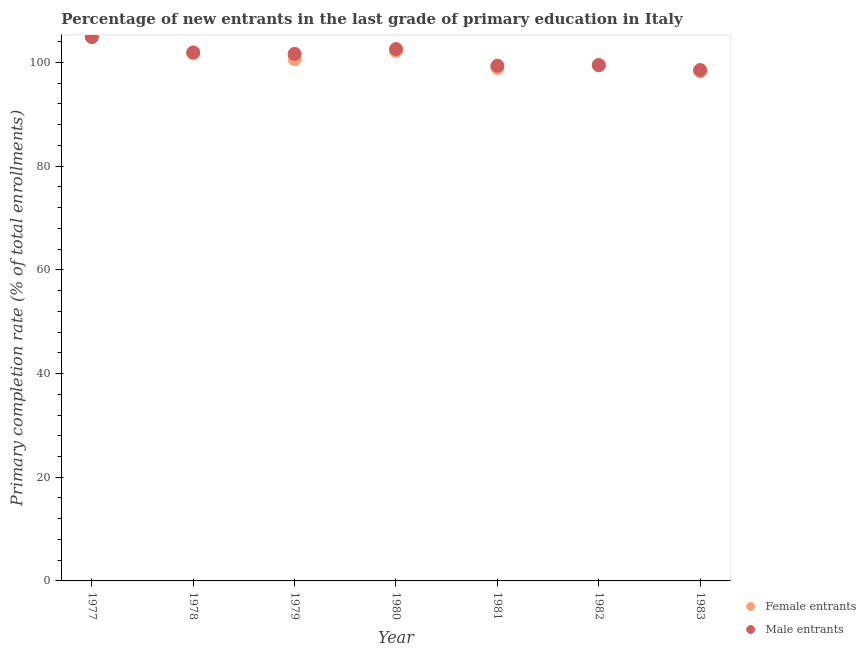What is the primary completion rate of male entrants in 1982?
Make the answer very short. 99.45. Across all years, what is the maximum primary completion rate of female entrants?
Give a very brief answer. 104.99. Across all years, what is the minimum primary completion rate of female entrants?
Make the answer very short. 98.28. In which year was the primary completion rate of female entrants minimum?
Provide a succinct answer. 1983. What is the total primary completion rate of female entrants in the graph?
Make the answer very short. 706.33. What is the difference between the primary completion rate of male entrants in 1978 and that in 1982?
Offer a terse response. 2.49. What is the difference between the primary completion rate of male entrants in 1982 and the primary completion rate of female entrants in 1981?
Your answer should be compact. 0.53. What is the average primary completion rate of female entrants per year?
Make the answer very short. 100.9. In the year 1980, what is the difference between the primary completion rate of female entrants and primary completion rate of male entrants?
Give a very brief answer. -0.38. In how many years, is the primary completion rate of male entrants greater than 92 %?
Provide a succinct answer. 7. What is the ratio of the primary completion rate of male entrants in 1978 to that in 1982?
Make the answer very short. 1.03. Is the primary completion rate of male entrants in 1981 less than that in 1983?
Offer a very short reply. No. Is the difference between the primary completion rate of female entrants in 1978 and 1983 greater than the difference between the primary completion rate of male entrants in 1978 and 1983?
Offer a very short reply. Yes. What is the difference between the highest and the second highest primary completion rate of female entrants?
Your response must be concise. 2.78. What is the difference between the highest and the lowest primary completion rate of female entrants?
Provide a short and direct response. 6.71. Does the primary completion rate of male entrants monotonically increase over the years?
Provide a succinct answer. No. Is the primary completion rate of female entrants strictly less than the primary completion rate of male entrants over the years?
Offer a very short reply. No. How many dotlines are there?
Your response must be concise. 2. Are the values on the major ticks of Y-axis written in scientific E-notation?
Offer a terse response. No. Does the graph contain grids?
Offer a terse response. No. How many legend labels are there?
Offer a very short reply. 2. How are the legend labels stacked?
Keep it short and to the point. Vertical. What is the title of the graph?
Your answer should be very brief. Percentage of new entrants in the last grade of primary education in Italy. What is the label or title of the X-axis?
Keep it short and to the point. Year. What is the label or title of the Y-axis?
Your answer should be very brief. Primary completion rate (% of total enrollments). What is the Primary completion rate (% of total enrollments) of Female entrants in 1977?
Provide a short and direct response. 104.99. What is the Primary completion rate (% of total enrollments) of Male entrants in 1977?
Provide a succinct answer. 104.89. What is the Primary completion rate (% of total enrollments) of Female entrants in 1978?
Give a very brief answer. 101.74. What is the Primary completion rate (% of total enrollments) in Male entrants in 1978?
Provide a succinct answer. 101.94. What is the Primary completion rate (% of total enrollments) in Female entrants in 1979?
Your answer should be very brief. 100.63. What is the Primary completion rate (% of total enrollments) in Male entrants in 1979?
Provide a succinct answer. 101.65. What is the Primary completion rate (% of total enrollments) in Female entrants in 1980?
Provide a short and direct response. 102.2. What is the Primary completion rate (% of total enrollments) of Male entrants in 1980?
Your response must be concise. 102.59. What is the Primary completion rate (% of total enrollments) in Female entrants in 1981?
Offer a very short reply. 98.92. What is the Primary completion rate (% of total enrollments) of Male entrants in 1981?
Provide a succinct answer. 99.37. What is the Primary completion rate (% of total enrollments) in Female entrants in 1982?
Provide a short and direct response. 99.57. What is the Primary completion rate (% of total enrollments) in Male entrants in 1982?
Your answer should be compact. 99.45. What is the Primary completion rate (% of total enrollments) of Female entrants in 1983?
Ensure brevity in your answer.  98.28. What is the Primary completion rate (% of total enrollments) in Male entrants in 1983?
Ensure brevity in your answer.  98.55. Across all years, what is the maximum Primary completion rate (% of total enrollments) of Female entrants?
Your answer should be very brief. 104.99. Across all years, what is the maximum Primary completion rate (% of total enrollments) in Male entrants?
Keep it short and to the point. 104.89. Across all years, what is the minimum Primary completion rate (% of total enrollments) in Female entrants?
Offer a very short reply. 98.28. Across all years, what is the minimum Primary completion rate (% of total enrollments) of Male entrants?
Your answer should be very brief. 98.55. What is the total Primary completion rate (% of total enrollments) in Female entrants in the graph?
Offer a very short reply. 706.33. What is the total Primary completion rate (% of total enrollments) in Male entrants in the graph?
Your response must be concise. 708.44. What is the difference between the Primary completion rate (% of total enrollments) in Female entrants in 1977 and that in 1978?
Make the answer very short. 3.24. What is the difference between the Primary completion rate (% of total enrollments) of Male entrants in 1977 and that in 1978?
Give a very brief answer. 2.95. What is the difference between the Primary completion rate (% of total enrollments) of Female entrants in 1977 and that in 1979?
Keep it short and to the point. 4.36. What is the difference between the Primary completion rate (% of total enrollments) in Male entrants in 1977 and that in 1979?
Keep it short and to the point. 3.24. What is the difference between the Primary completion rate (% of total enrollments) of Female entrants in 1977 and that in 1980?
Offer a very short reply. 2.78. What is the difference between the Primary completion rate (% of total enrollments) of Male entrants in 1977 and that in 1980?
Keep it short and to the point. 2.31. What is the difference between the Primary completion rate (% of total enrollments) of Female entrants in 1977 and that in 1981?
Make the answer very short. 6.07. What is the difference between the Primary completion rate (% of total enrollments) in Male entrants in 1977 and that in 1981?
Your answer should be very brief. 5.53. What is the difference between the Primary completion rate (% of total enrollments) of Female entrants in 1977 and that in 1982?
Your response must be concise. 5.42. What is the difference between the Primary completion rate (% of total enrollments) in Male entrants in 1977 and that in 1982?
Give a very brief answer. 5.44. What is the difference between the Primary completion rate (% of total enrollments) of Female entrants in 1977 and that in 1983?
Ensure brevity in your answer.  6.71. What is the difference between the Primary completion rate (% of total enrollments) in Male entrants in 1977 and that in 1983?
Your response must be concise. 6.35. What is the difference between the Primary completion rate (% of total enrollments) of Female entrants in 1978 and that in 1979?
Your answer should be compact. 1.11. What is the difference between the Primary completion rate (% of total enrollments) in Male entrants in 1978 and that in 1979?
Your answer should be very brief. 0.29. What is the difference between the Primary completion rate (% of total enrollments) of Female entrants in 1978 and that in 1980?
Your answer should be compact. -0.46. What is the difference between the Primary completion rate (% of total enrollments) in Male entrants in 1978 and that in 1980?
Make the answer very short. -0.65. What is the difference between the Primary completion rate (% of total enrollments) of Female entrants in 1978 and that in 1981?
Offer a very short reply. 2.83. What is the difference between the Primary completion rate (% of total enrollments) in Male entrants in 1978 and that in 1981?
Offer a terse response. 2.58. What is the difference between the Primary completion rate (% of total enrollments) of Female entrants in 1978 and that in 1982?
Your answer should be very brief. 2.17. What is the difference between the Primary completion rate (% of total enrollments) of Male entrants in 1978 and that in 1982?
Your response must be concise. 2.49. What is the difference between the Primary completion rate (% of total enrollments) in Female entrants in 1978 and that in 1983?
Your answer should be very brief. 3.46. What is the difference between the Primary completion rate (% of total enrollments) of Male entrants in 1978 and that in 1983?
Give a very brief answer. 3.39. What is the difference between the Primary completion rate (% of total enrollments) of Female entrants in 1979 and that in 1980?
Give a very brief answer. -1.57. What is the difference between the Primary completion rate (% of total enrollments) of Male entrants in 1979 and that in 1980?
Your answer should be very brief. -0.94. What is the difference between the Primary completion rate (% of total enrollments) of Female entrants in 1979 and that in 1981?
Your answer should be compact. 1.71. What is the difference between the Primary completion rate (% of total enrollments) in Male entrants in 1979 and that in 1981?
Make the answer very short. 2.28. What is the difference between the Primary completion rate (% of total enrollments) of Female entrants in 1979 and that in 1982?
Your answer should be compact. 1.06. What is the difference between the Primary completion rate (% of total enrollments) of Male entrants in 1979 and that in 1982?
Your answer should be compact. 2.2. What is the difference between the Primary completion rate (% of total enrollments) of Female entrants in 1979 and that in 1983?
Offer a terse response. 2.35. What is the difference between the Primary completion rate (% of total enrollments) of Male entrants in 1979 and that in 1983?
Ensure brevity in your answer.  3.1. What is the difference between the Primary completion rate (% of total enrollments) in Female entrants in 1980 and that in 1981?
Offer a terse response. 3.29. What is the difference between the Primary completion rate (% of total enrollments) of Male entrants in 1980 and that in 1981?
Provide a short and direct response. 3.22. What is the difference between the Primary completion rate (% of total enrollments) in Female entrants in 1980 and that in 1982?
Make the answer very short. 2.63. What is the difference between the Primary completion rate (% of total enrollments) in Male entrants in 1980 and that in 1982?
Keep it short and to the point. 3.14. What is the difference between the Primary completion rate (% of total enrollments) in Female entrants in 1980 and that in 1983?
Your response must be concise. 3.92. What is the difference between the Primary completion rate (% of total enrollments) in Male entrants in 1980 and that in 1983?
Provide a short and direct response. 4.04. What is the difference between the Primary completion rate (% of total enrollments) of Female entrants in 1981 and that in 1982?
Make the answer very short. -0.66. What is the difference between the Primary completion rate (% of total enrollments) of Male entrants in 1981 and that in 1982?
Offer a very short reply. -0.09. What is the difference between the Primary completion rate (% of total enrollments) in Female entrants in 1981 and that in 1983?
Make the answer very short. 0.64. What is the difference between the Primary completion rate (% of total enrollments) in Male entrants in 1981 and that in 1983?
Provide a succinct answer. 0.82. What is the difference between the Primary completion rate (% of total enrollments) of Female entrants in 1982 and that in 1983?
Your answer should be compact. 1.29. What is the difference between the Primary completion rate (% of total enrollments) in Male entrants in 1982 and that in 1983?
Give a very brief answer. 0.9. What is the difference between the Primary completion rate (% of total enrollments) of Female entrants in 1977 and the Primary completion rate (% of total enrollments) of Male entrants in 1978?
Your response must be concise. 3.05. What is the difference between the Primary completion rate (% of total enrollments) of Female entrants in 1977 and the Primary completion rate (% of total enrollments) of Male entrants in 1979?
Your answer should be very brief. 3.34. What is the difference between the Primary completion rate (% of total enrollments) in Female entrants in 1977 and the Primary completion rate (% of total enrollments) in Male entrants in 1980?
Offer a very short reply. 2.4. What is the difference between the Primary completion rate (% of total enrollments) in Female entrants in 1977 and the Primary completion rate (% of total enrollments) in Male entrants in 1981?
Make the answer very short. 5.62. What is the difference between the Primary completion rate (% of total enrollments) in Female entrants in 1977 and the Primary completion rate (% of total enrollments) in Male entrants in 1982?
Your answer should be very brief. 5.54. What is the difference between the Primary completion rate (% of total enrollments) in Female entrants in 1977 and the Primary completion rate (% of total enrollments) in Male entrants in 1983?
Give a very brief answer. 6.44. What is the difference between the Primary completion rate (% of total enrollments) in Female entrants in 1978 and the Primary completion rate (% of total enrollments) in Male entrants in 1979?
Your answer should be compact. 0.09. What is the difference between the Primary completion rate (% of total enrollments) of Female entrants in 1978 and the Primary completion rate (% of total enrollments) of Male entrants in 1980?
Make the answer very short. -0.84. What is the difference between the Primary completion rate (% of total enrollments) in Female entrants in 1978 and the Primary completion rate (% of total enrollments) in Male entrants in 1981?
Provide a succinct answer. 2.38. What is the difference between the Primary completion rate (% of total enrollments) of Female entrants in 1978 and the Primary completion rate (% of total enrollments) of Male entrants in 1982?
Provide a succinct answer. 2.29. What is the difference between the Primary completion rate (% of total enrollments) of Female entrants in 1978 and the Primary completion rate (% of total enrollments) of Male entrants in 1983?
Your answer should be very brief. 3.2. What is the difference between the Primary completion rate (% of total enrollments) in Female entrants in 1979 and the Primary completion rate (% of total enrollments) in Male entrants in 1980?
Make the answer very short. -1.96. What is the difference between the Primary completion rate (% of total enrollments) of Female entrants in 1979 and the Primary completion rate (% of total enrollments) of Male entrants in 1981?
Ensure brevity in your answer.  1.26. What is the difference between the Primary completion rate (% of total enrollments) of Female entrants in 1979 and the Primary completion rate (% of total enrollments) of Male entrants in 1982?
Ensure brevity in your answer.  1.18. What is the difference between the Primary completion rate (% of total enrollments) of Female entrants in 1979 and the Primary completion rate (% of total enrollments) of Male entrants in 1983?
Your answer should be very brief. 2.08. What is the difference between the Primary completion rate (% of total enrollments) of Female entrants in 1980 and the Primary completion rate (% of total enrollments) of Male entrants in 1981?
Your answer should be compact. 2.84. What is the difference between the Primary completion rate (% of total enrollments) of Female entrants in 1980 and the Primary completion rate (% of total enrollments) of Male entrants in 1982?
Offer a very short reply. 2.75. What is the difference between the Primary completion rate (% of total enrollments) in Female entrants in 1980 and the Primary completion rate (% of total enrollments) in Male entrants in 1983?
Your answer should be very brief. 3.66. What is the difference between the Primary completion rate (% of total enrollments) in Female entrants in 1981 and the Primary completion rate (% of total enrollments) in Male entrants in 1982?
Ensure brevity in your answer.  -0.53. What is the difference between the Primary completion rate (% of total enrollments) of Female entrants in 1981 and the Primary completion rate (% of total enrollments) of Male entrants in 1983?
Provide a succinct answer. 0.37. What is the difference between the Primary completion rate (% of total enrollments) of Female entrants in 1982 and the Primary completion rate (% of total enrollments) of Male entrants in 1983?
Offer a terse response. 1.02. What is the average Primary completion rate (% of total enrollments) in Female entrants per year?
Keep it short and to the point. 100.9. What is the average Primary completion rate (% of total enrollments) of Male entrants per year?
Your answer should be very brief. 101.21. In the year 1977, what is the difference between the Primary completion rate (% of total enrollments) in Female entrants and Primary completion rate (% of total enrollments) in Male entrants?
Make the answer very short. 0.09. In the year 1978, what is the difference between the Primary completion rate (% of total enrollments) of Female entrants and Primary completion rate (% of total enrollments) of Male entrants?
Ensure brevity in your answer.  -0.2. In the year 1979, what is the difference between the Primary completion rate (% of total enrollments) in Female entrants and Primary completion rate (% of total enrollments) in Male entrants?
Your response must be concise. -1.02. In the year 1980, what is the difference between the Primary completion rate (% of total enrollments) in Female entrants and Primary completion rate (% of total enrollments) in Male entrants?
Make the answer very short. -0.38. In the year 1981, what is the difference between the Primary completion rate (% of total enrollments) in Female entrants and Primary completion rate (% of total enrollments) in Male entrants?
Make the answer very short. -0.45. In the year 1982, what is the difference between the Primary completion rate (% of total enrollments) in Female entrants and Primary completion rate (% of total enrollments) in Male entrants?
Keep it short and to the point. 0.12. In the year 1983, what is the difference between the Primary completion rate (% of total enrollments) in Female entrants and Primary completion rate (% of total enrollments) in Male entrants?
Offer a very short reply. -0.27. What is the ratio of the Primary completion rate (% of total enrollments) of Female entrants in 1977 to that in 1978?
Make the answer very short. 1.03. What is the ratio of the Primary completion rate (% of total enrollments) of Female entrants in 1977 to that in 1979?
Your answer should be very brief. 1.04. What is the ratio of the Primary completion rate (% of total enrollments) in Male entrants in 1977 to that in 1979?
Give a very brief answer. 1.03. What is the ratio of the Primary completion rate (% of total enrollments) in Female entrants in 1977 to that in 1980?
Ensure brevity in your answer.  1.03. What is the ratio of the Primary completion rate (% of total enrollments) in Male entrants in 1977 to that in 1980?
Offer a very short reply. 1.02. What is the ratio of the Primary completion rate (% of total enrollments) in Female entrants in 1977 to that in 1981?
Provide a short and direct response. 1.06. What is the ratio of the Primary completion rate (% of total enrollments) of Male entrants in 1977 to that in 1981?
Offer a terse response. 1.06. What is the ratio of the Primary completion rate (% of total enrollments) of Female entrants in 1977 to that in 1982?
Your response must be concise. 1.05. What is the ratio of the Primary completion rate (% of total enrollments) of Male entrants in 1977 to that in 1982?
Ensure brevity in your answer.  1.05. What is the ratio of the Primary completion rate (% of total enrollments) of Female entrants in 1977 to that in 1983?
Make the answer very short. 1.07. What is the ratio of the Primary completion rate (% of total enrollments) of Male entrants in 1977 to that in 1983?
Offer a terse response. 1.06. What is the ratio of the Primary completion rate (% of total enrollments) in Female entrants in 1978 to that in 1979?
Provide a short and direct response. 1.01. What is the ratio of the Primary completion rate (% of total enrollments) of Male entrants in 1978 to that in 1979?
Your answer should be very brief. 1. What is the ratio of the Primary completion rate (% of total enrollments) in Female entrants in 1978 to that in 1981?
Give a very brief answer. 1.03. What is the ratio of the Primary completion rate (% of total enrollments) of Male entrants in 1978 to that in 1981?
Make the answer very short. 1.03. What is the ratio of the Primary completion rate (% of total enrollments) of Female entrants in 1978 to that in 1982?
Give a very brief answer. 1.02. What is the ratio of the Primary completion rate (% of total enrollments) in Male entrants in 1978 to that in 1982?
Ensure brevity in your answer.  1.02. What is the ratio of the Primary completion rate (% of total enrollments) in Female entrants in 1978 to that in 1983?
Your answer should be compact. 1.04. What is the ratio of the Primary completion rate (% of total enrollments) of Male entrants in 1978 to that in 1983?
Ensure brevity in your answer.  1.03. What is the ratio of the Primary completion rate (% of total enrollments) in Female entrants in 1979 to that in 1980?
Give a very brief answer. 0.98. What is the ratio of the Primary completion rate (% of total enrollments) in Male entrants in 1979 to that in 1980?
Your response must be concise. 0.99. What is the ratio of the Primary completion rate (% of total enrollments) in Female entrants in 1979 to that in 1981?
Give a very brief answer. 1.02. What is the ratio of the Primary completion rate (% of total enrollments) in Female entrants in 1979 to that in 1982?
Provide a short and direct response. 1.01. What is the ratio of the Primary completion rate (% of total enrollments) of Male entrants in 1979 to that in 1982?
Ensure brevity in your answer.  1.02. What is the ratio of the Primary completion rate (% of total enrollments) of Female entrants in 1979 to that in 1983?
Your answer should be compact. 1.02. What is the ratio of the Primary completion rate (% of total enrollments) in Male entrants in 1979 to that in 1983?
Offer a terse response. 1.03. What is the ratio of the Primary completion rate (% of total enrollments) in Female entrants in 1980 to that in 1981?
Offer a very short reply. 1.03. What is the ratio of the Primary completion rate (% of total enrollments) in Male entrants in 1980 to that in 1981?
Keep it short and to the point. 1.03. What is the ratio of the Primary completion rate (% of total enrollments) of Female entrants in 1980 to that in 1982?
Make the answer very short. 1.03. What is the ratio of the Primary completion rate (% of total enrollments) in Male entrants in 1980 to that in 1982?
Your answer should be very brief. 1.03. What is the ratio of the Primary completion rate (% of total enrollments) in Female entrants in 1980 to that in 1983?
Your answer should be very brief. 1.04. What is the ratio of the Primary completion rate (% of total enrollments) of Male entrants in 1980 to that in 1983?
Make the answer very short. 1.04. What is the ratio of the Primary completion rate (% of total enrollments) in Female entrants in 1981 to that in 1982?
Ensure brevity in your answer.  0.99. What is the ratio of the Primary completion rate (% of total enrollments) in Male entrants in 1981 to that in 1982?
Keep it short and to the point. 1. What is the ratio of the Primary completion rate (% of total enrollments) of Male entrants in 1981 to that in 1983?
Make the answer very short. 1.01. What is the ratio of the Primary completion rate (% of total enrollments) of Female entrants in 1982 to that in 1983?
Your answer should be very brief. 1.01. What is the ratio of the Primary completion rate (% of total enrollments) in Male entrants in 1982 to that in 1983?
Your answer should be compact. 1.01. What is the difference between the highest and the second highest Primary completion rate (% of total enrollments) in Female entrants?
Provide a short and direct response. 2.78. What is the difference between the highest and the second highest Primary completion rate (% of total enrollments) of Male entrants?
Ensure brevity in your answer.  2.31. What is the difference between the highest and the lowest Primary completion rate (% of total enrollments) of Female entrants?
Provide a short and direct response. 6.71. What is the difference between the highest and the lowest Primary completion rate (% of total enrollments) of Male entrants?
Give a very brief answer. 6.35. 